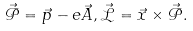<formula> <loc_0><loc_0><loc_500><loc_500>\mathcal { \vec { P } } = \vec { p } - e \vec { A } , \mathcal { \vec { L } } = \vec { x } \times \mathcal { \vec { P } } .</formula> 